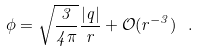<formula> <loc_0><loc_0><loc_500><loc_500>\phi = \sqrt { \frac { 3 } { 4 \pi } } \frac { | q | } { r } + \mathcal { O } ( r ^ { - 3 } ) \ .</formula> 